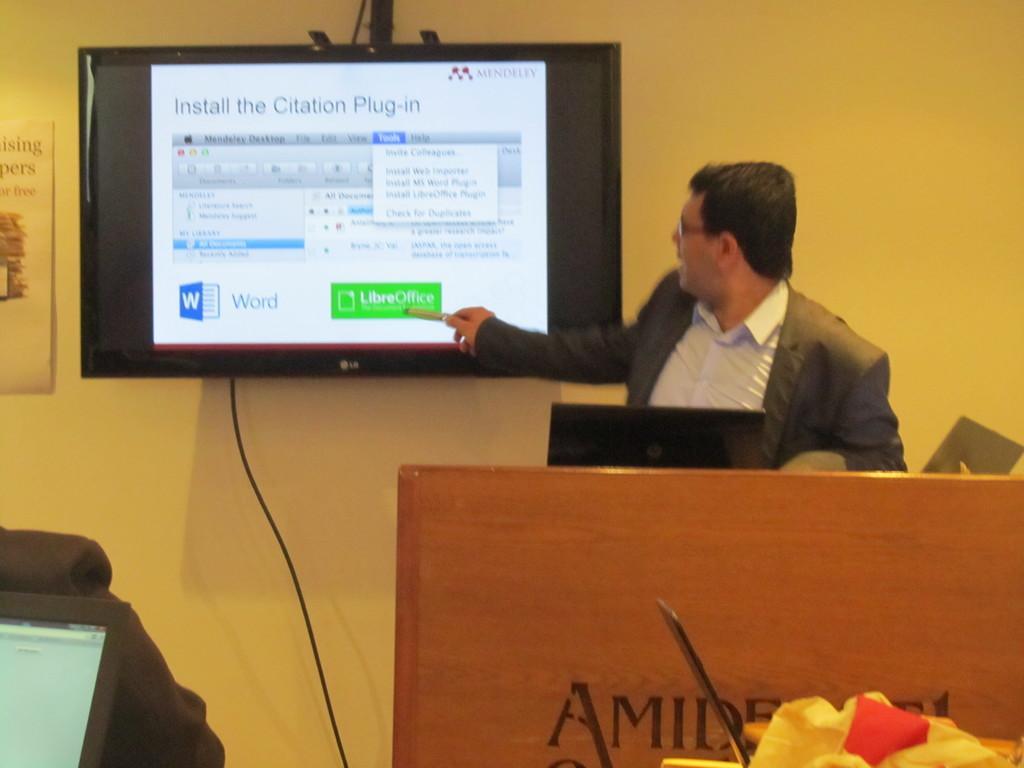In one or two sentences, can you explain what this image depicts? This is the man standing. I can see a television screen and a poster, which are attached to the wall. This is a wire, which is connected to the television. I think this is a laptop, which is placed on the podium. At the bottom left corner of the image, that looks like a laptop. 